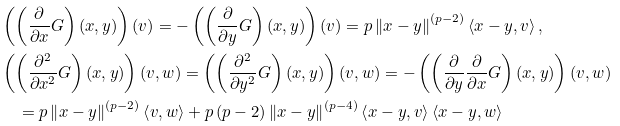<formula> <loc_0><loc_0><loc_500><loc_500>& \left ( \left ( \frac { \partial } { \partial x } G \right ) ( x , y ) \right ) ( v ) = - \left ( \left ( \frac { \partial } { \partial y } G \right ) ( x , y ) \right ) ( v ) = p \left \| x - y \right \| ^ { ( p - 2 ) } \left < x - y , v \right > , \\ & \left ( \left ( \frac { \partial ^ { 2 } } { \partial x ^ { 2 } } G \right ) ( x , y ) \right ) ( v , w ) = \left ( \left ( \frac { \partial ^ { 2 } } { \partial y ^ { 2 } } G \right ) ( x , y ) \right ) ( v , w ) = - \left ( \left ( \frac { \partial } { \partial y } \frac { \partial } { \partial x } G \right ) ( x , y ) \right ) ( v , w ) \\ & \quad = p \left \| x - y \right \| ^ { ( p - 2 ) } \left < v , w \right > + p \left ( p - 2 \right ) \left \| x - y \right \| ^ { ( p - 4 ) } \left < x - y , v \right > \left < x - y , w \right ></formula> 